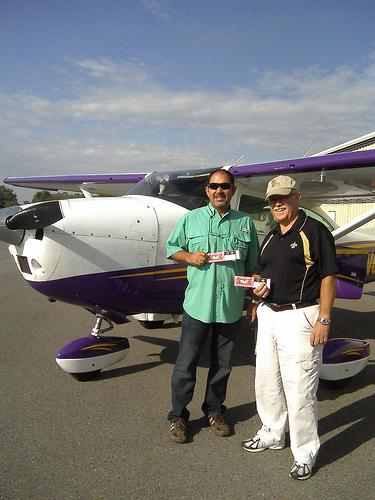Question: how many hats are in the picture?
Choices:
A. Twelve.
B. One.
C. Three.
D. Five.
Answer with the letter. Answer: B Question: what type of shoes are they wearing?
Choices:
A. Flip flops.
B. Boots.
C. Sandals.
D. Sneakers.
Answer with the letter. Answer: D Question: what color is the ground?
Choices:
A. Green.
B. Red.
C. Brown.
D. Grey.
Answer with the letter. Answer: D Question: how many people are in the picture?
Choices:
A. About Twenty.
B. Six.
C. Two.
D. Twelve.
Answer with the letter. Answer: C 